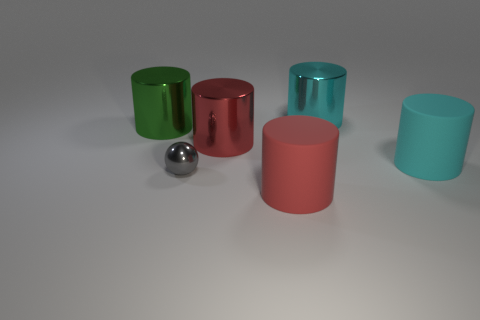Subtract 1 cylinders. How many cylinders are left? 4 Subtract all brown cylinders. Subtract all gray cubes. How many cylinders are left? 5 Add 3 green cylinders. How many objects exist? 9 Subtract all cylinders. How many objects are left? 1 Add 3 small gray metal balls. How many small gray metal balls are left? 4 Add 3 cylinders. How many cylinders exist? 8 Subtract 0 green spheres. How many objects are left? 6 Subtract all large purple balls. Subtract all metal cylinders. How many objects are left? 3 